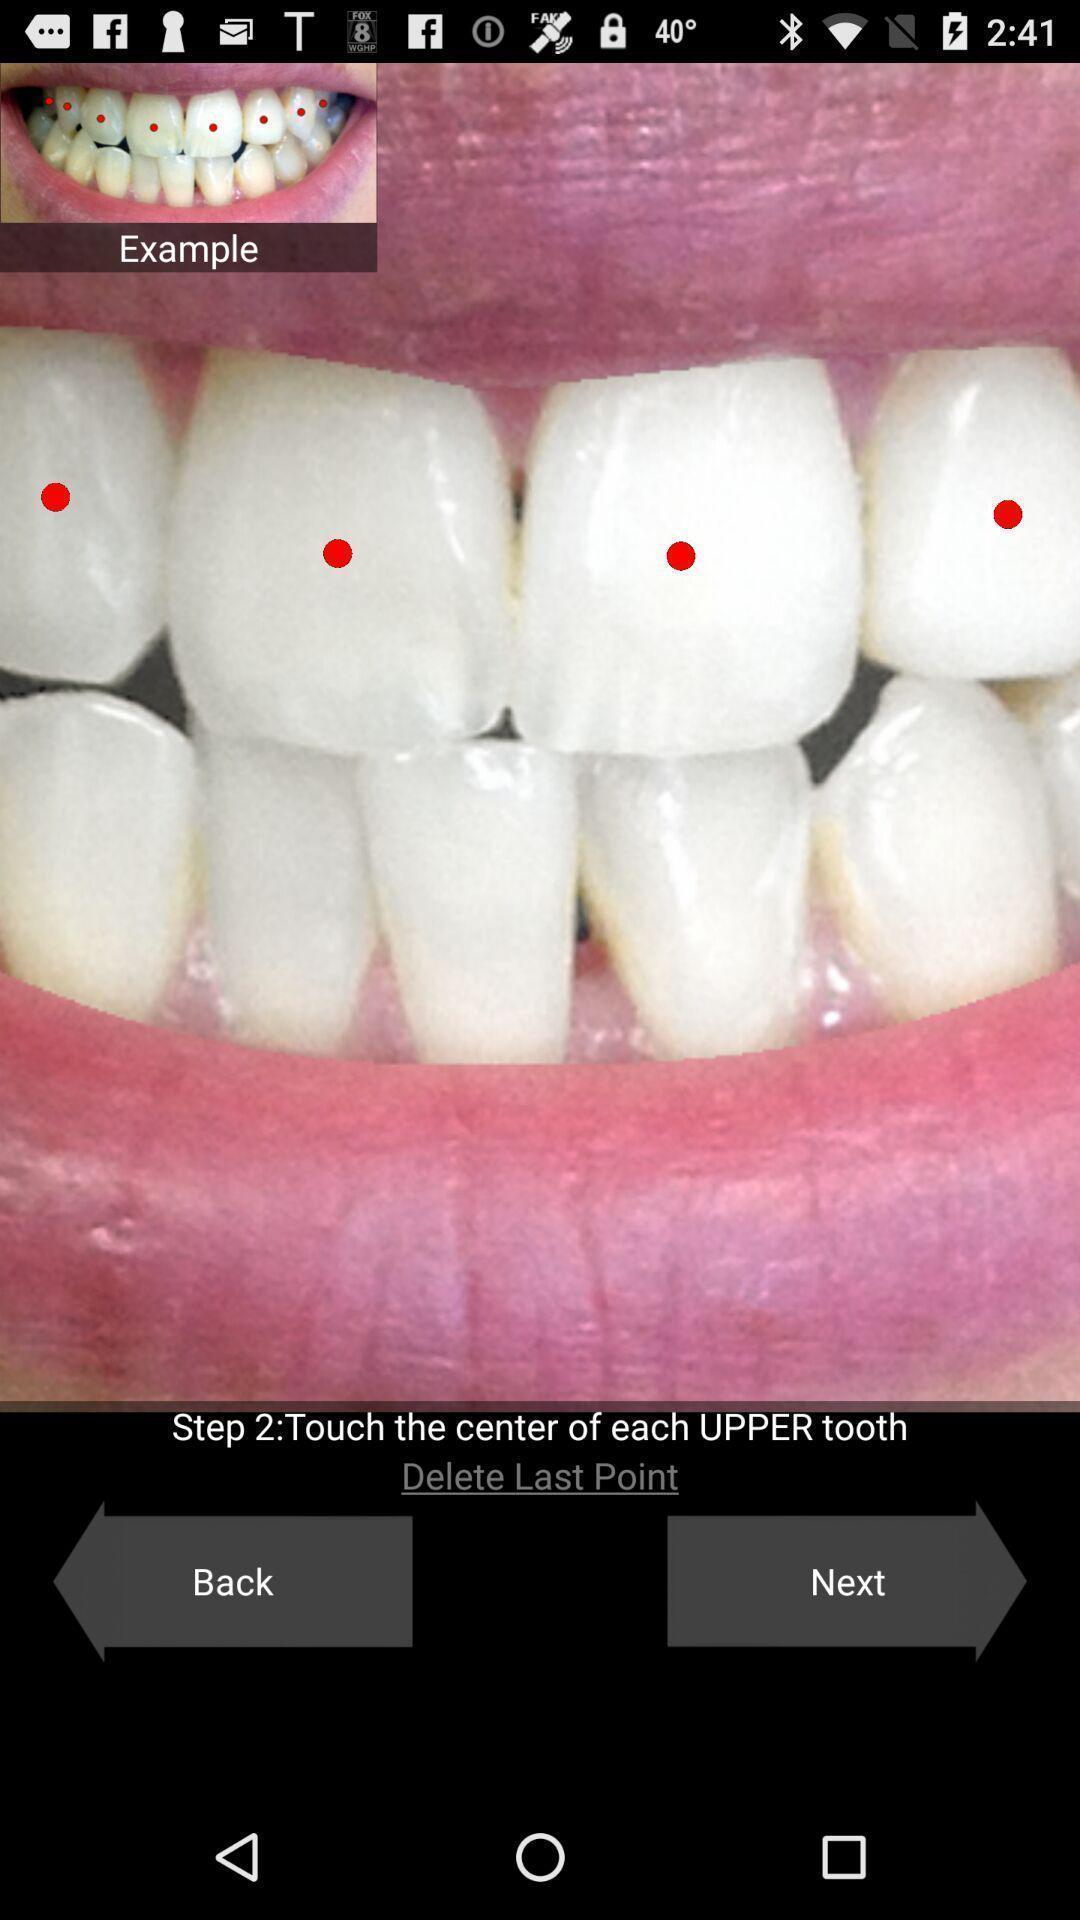Explain what's happening in this screen capture. Screen showing various options like next. 